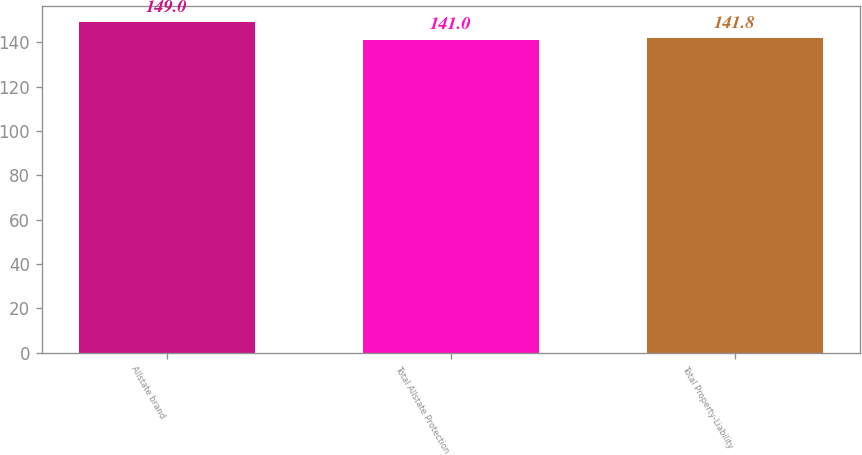Convert chart to OTSL. <chart><loc_0><loc_0><loc_500><loc_500><bar_chart><fcel>Allstate brand<fcel>Total Allstate Protection<fcel>Total Property-Liability<nl><fcel>149<fcel>141<fcel>141.8<nl></chart> 